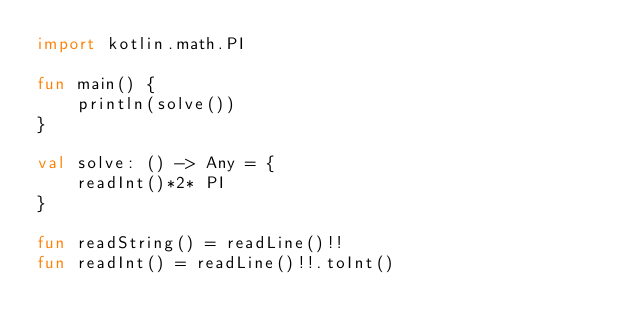Convert code to text. <code><loc_0><loc_0><loc_500><loc_500><_Kotlin_>import kotlin.math.PI

fun main() {
    println(solve())
}

val solve: () -> Any = {
    readInt()*2* PI
}

fun readString() = readLine()!!
fun readInt() = readLine()!!.toInt()</code> 